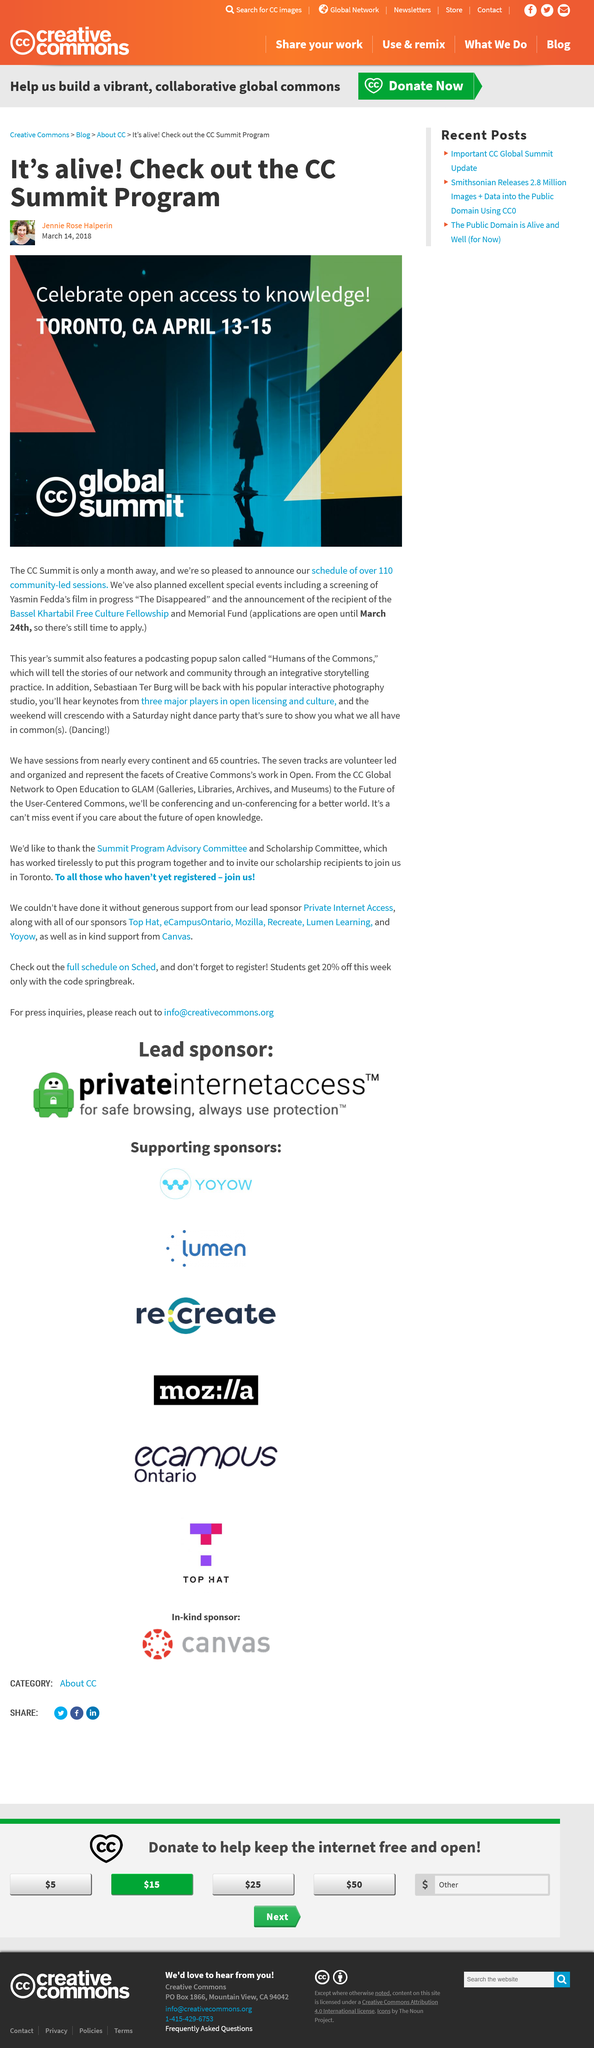Identify some key points in this picture. There will be more than 110 community-led sessions at the CC Global Summit. The Bassel Khartabil Free Culture Fellowship and Memorial Fund will close on March 24th, 2018. I will have the opportunity to view a screening of Yasmin Fedda's film 'The Disappeared' at the CC Global Summit, which will take place between April 13-15, 2018. 